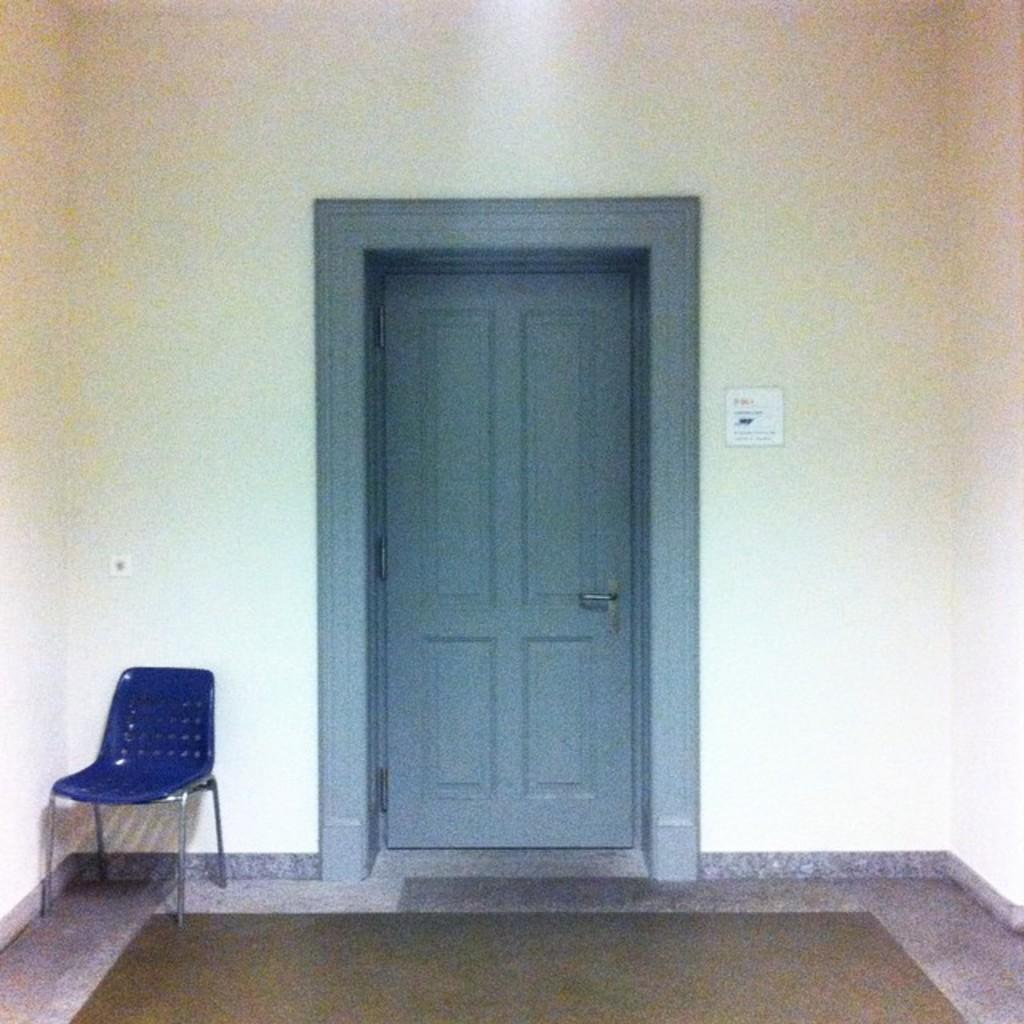What type of door is visible in the image? There is a wooden door in the image. What color is the chair in the image? The chair in the image is blue. Where is the blue chair located in relation to the wall? The blue chair is in front of a wall. What type of mountain can be seen in the image? There is no mountain present in the image; it features a wooden door and a blue chair in front of a wall. How many noses are visible in the image? There are no noses visible in the image. 